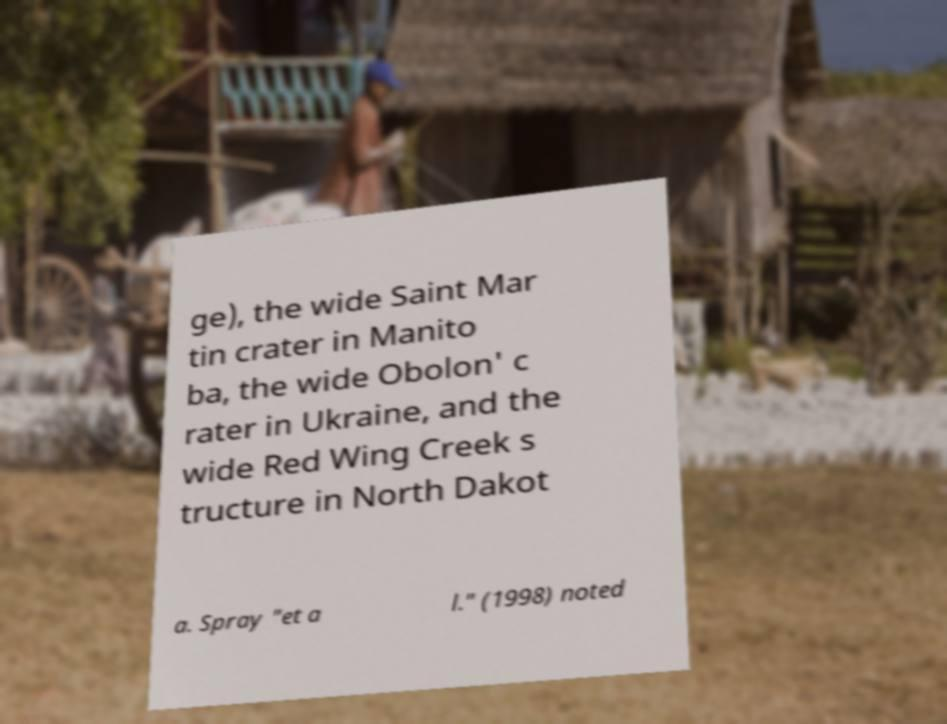For documentation purposes, I need the text within this image transcribed. Could you provide that? ge), the wide Saint Mar tin crater in Manito ba, the wide Obolon' c rater in Ukraine, and the wide Red Wing Creek s tructure in North Dakot a. Spray "et a l." (1998) noted 